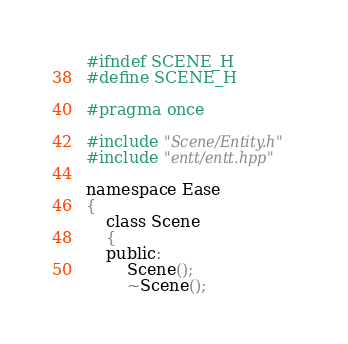<code> <loc_0><loc_0><loc_500><loc_500><_C_>#ifndef SCENE_H
#define SCENE_H

#pragma once

#include "Scene/Entity.h"
#include "entt/entt.hpp"

namespace Ease
{
    class Scene
    {
    public:
        Scene();
        ~Scene();</code> 